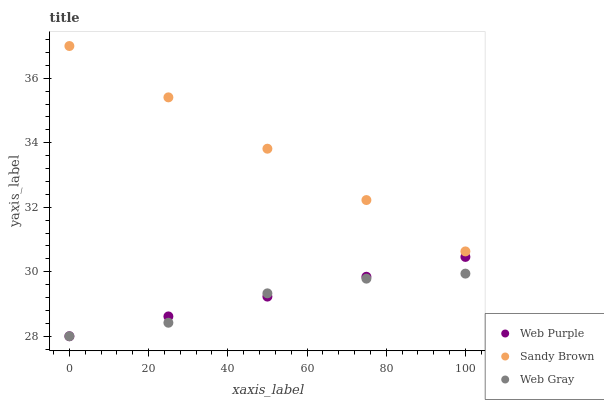Does Web Gray have the minimum area under the curve?
Answer yes or no. Yes. Does Sandy Brown have the maximum area under the curve?
Answer yes or no. Yes. Does Sandy Brown have the minimum area under the curve?
Answer yes or no. No. Does Web Gray have the maximum area under the curve?
Answer yes or no. No. Is Web Purple the smoothest?
Answer yes or no. Yes. Is Web Gray the roughest?
Answer yes or no. Yes. Is Web Gray the smoothest?
Answer yes or no. No. Is Sandy Brown the roughest?
Answer yes or no. No. Does Web Purple have the lowest value?
Answer yes or no. Yes. Does Sandy Brown have the lowest value?
Answer yes or no. No. Does Sandy Brown have the highest value?
Answer yes or no. Yes. Does Web Gray have the highest value?
Answer yes or no. No. Is Web Gray less than Sandy Brown?
Answer yes or no. Yes. Is Sandy Brown greater than Web Purple?
Answer yes or no. Yes. Does Web Purple intersect Web Gray?
Answer yes or no. Yes. Is Web Purple less than Web Gray?
Answer yes or no. No. Is Web Purple greater than Web Gray?
Answer yes or no. No. Does Web Gray intersect Sandy Brown?
Answer yes or no. No. 